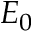<formula> <loc_0><loc_0><loc_500><loc_500>E _ { 0 }</formula> 